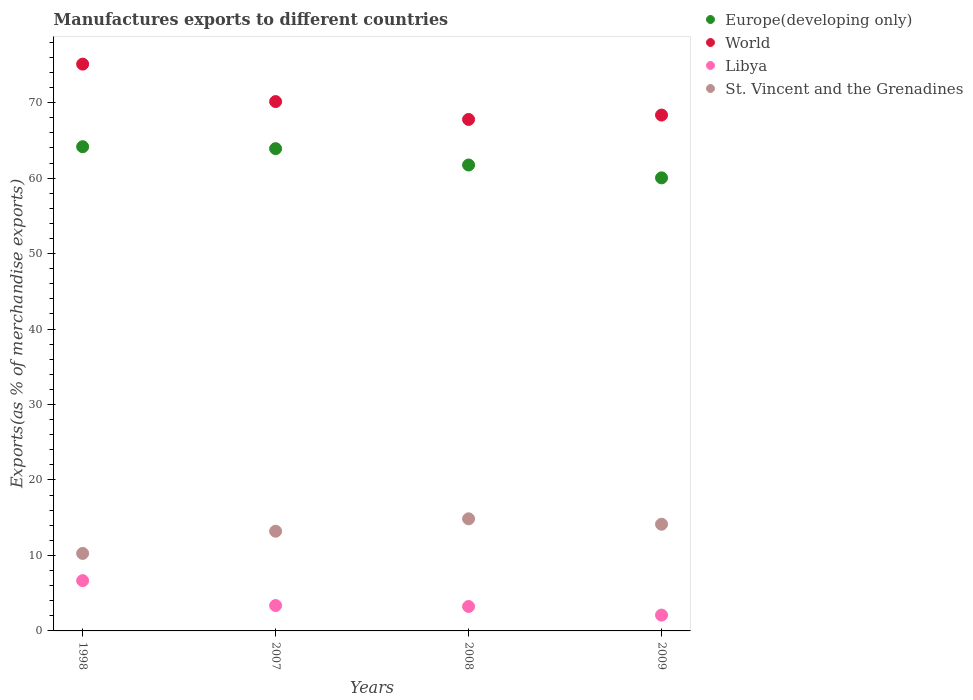Is the number of dotlines equal to the number of legend labels?
Your answer should be very brief. Yes. What is the percentage of exports to different countries in World in 1998?
Your response must be concise. 75.1. Across all years, what is the maximum percentage of exports to different countries in St. Vincent and the Grenadines?
Provide a succinct answer. 14.85. Across all years, what is the minimum percentage of exports to different countries in Libya?
Keep it short and to the point. 2.1. In which year was the percentage of exports to different countries in World maximum?
Keep it short and to the point. 1998. What is the total percentage of exports to different countries in St. Vincent and the Grenadines in the graph?
Provide a short and direct response. 52.47. What is the difference between the percentage of exports to different countries in St. Vincent and the Grenadines in 1998 and that in 2009?
Provide a succinct answer. -3.87. What is the difference between the percentage of exports to different countries in Libya in 1998 and the percentage of exports to different countries in Europe(developing only) in 2009?
Keep it short and to the point. -53.37. What is the average percentage of exports to different countries in Europe(developing only) per year?
Provide a succinct answer. 62.46. In the year 2009, what is the difference between the percentage of exports to different countries in World and percentage of exports to different countries in Europe(developing only)?
Provide a short and direct response. 8.32. In how many years, is the percentage of exports to different countries in World greater than 6 %?
Your answer should be compact. 4. What is the ratio of the percentage of exports to different countries in Europe(developing only) in 1998 to that in 2009?
Give a very brief answer. 1.07. Is the difference between the percentage of exports to different countries in World in 1998 and 2009 greater than the difference between the percentage of exports to different countries in Europe(developing only) in 1998 and 2009?
Your response must be concise. Yes. What is the difference between the highest and the second highest percentage of exports to different countries in World?
Your response must be concise. 4.96. What is the difference between the highest and the lowest percentage of exports to different countries in St. Vincent and the Grenadines?
Your answer should be very brief. 4.58. Is it the case that in every year, the sum of the percentage of exports to different countries in St. Vincent and the Grenadines and percentage of exports to different countries in Libya  is greater than the sum of percentage of exports to different countries in Europe(developing only) and percentage of exports to different countries in World?
Your answer should be very brief. No. How many dotlines are there?
Offer a terse response. 4. How many years are there in the graph?
Your answer should be very brief. 4. What is the difference between two consecutive major ticks on the Y-axis?
Provide a short and direct response. 10. Where does the legend appear in the graph?
Your answer should be compact. Top right. How many legend labels are there?
Provide a succinct answer. 4. How are the legend labels stacked?
Provide a short and direct response. Vertical. What is the title of the graph?
Provide a succinct answer. Manufactures exports to different countries. What is the label or title of the X-axis?
Provide a succinct answer. Years. What is the label or title of the Y-axis?
Your answer should be compact. Exports(as % of merchandise exports). What is the Exports(as % of merchandise exports) of Europe(developing only) in 1998?
Keep it short and to the point. 64.16. What is the Exports(as % of merchandise exports) of World in 1998?
Ensure brevity in your answer.  75.1. What is the Exports(as % of merchandise exports) of Libya in 1998?
Provide a succinct answer. 6.66. What is the Exports(as % of merchandise exports) in St. Vincent and the Grenadines in 1998?
Offer a very short reply. 10.27. What is the Exports(as % of merchandise exports) in Europe(developing only) in 2007?
Keep it short and to the point. 63.9. What is the Exports(as % of merchandise exports) of World in 2007?
Your response must be concise. 70.14. What is the Exports(as % of merchandise exports) of Libya in 2007?
Your answer should be compact. 3.36. What is the Exports(as % of merchandise exports) of St. Vincent and the Grenadines in 2007?
Provide a short and direct response. 13.21. What is the Exports(as % of merchandise exports) in Europe(developing only) in 2008?
Provide a short and direct response. 61.74. What is the Exports(as % of merchandise exports) of World in 2008?
Offer a terse response. 67.77. What is the Exports(as % of merchandise exports) of Libya in 2008?
Offer a very short reply. 3.24. What is the Exports(as % of merchandise exports) of St. Vincent and the Grenadines in 2008?
Give a very brief answer. 14.85. What is the Exports(as % of merchandise exports) of Europe(developing only) in 2009?
Your answer should be compact. 60.04. What is the Exports(as % of merchandise exports) of World in 2009?
Offer a terse response. 68.36. What is the Exports(as % of merchandise exports) in Libya in 2009?
Give a very brief answer. 2.1. What is the Exports(as % of merchandise exports) in St. Vincent and the Grenadines in 2009?
Give a very brief answer. 14.14. Across all years, what is the maximum Exports(as % of merchandise exports) in Europe(developing only)?
Provide a short and direct response. 64.16. Across all years, what is the maximum Exports(as % of merchandise exports) in World?
Your answer should be compact. 75.1. Across all years, what is the maximum Exports(as % of merchandise exports) of Libya?
Your answer should be compact. 6.66. Across all years, what is the maximum Exports(as % of merchandise exports) of St. Vincent and the Grenadines?
Keep it short and to the point. 14.85. Across all years, what is the minimum Exports(as % of merchandise exports) in Europe(developing only)?
Ensure brevity in your answer.  60.04. Across all years, what is the minimum Exports(as % of merchandise exports) in World?
Offer a terse response. 67.77. Across all years, what is the minimum Exports(as % of merchandise exports) in Libya?
Offer a very short reply. 2.1. Across all years, what is the minimum Exports(as % of merchandise exports) in St. Vincent and the Grenadines?
Offer a very short reply. 10.27. What is the total Exports(as % of merchandise exports) in Europe(developing only) in the graph?
Offer a terse response. 249.84. What is the total Exports(as % of merchandise exports) of World in the graph?
Offer a very short reply. 281.37. What is the total Exports(as % of merchandise exports) in Libya in the graph?
Provide a succinct answer. 15.36. What is the total Exports(as % of merchandise exports) of St. Vincent and the Grenadines in the graph?
Provide a short and direct response. 52.47. What is the difference between the Exports(as % of merchandise exports) in Europe(developing only) in 1998 and that in 2007?
Your answer should be very brief. 0.26. What is the difference between the Exports(as % of merchandise exports) in World in 1998 and that in 2007?
Offer a very short reply. 4.96. What is the difference between the Exports(as % of merchandise exports) in Libya in 1998 and that in 2007?
Provide a succinct answer. 3.3. What is the difference between the Exports(as % of merchandise exports) in St. Vincent and the Grenadines in 1998 and that in 2007?
Your answer should be very brief. -2.94. What is the difference between the Exports(as % of merchandise exports) of Europe(developing only) in 1998 and that in 2008?
Ensure brevity in your answer.  2.42. What is the difference between the Exports(as % of merchandise exports) in World in 1998 and that in 2008?
Keep it short and to the point. 7.33. What is the difference between the Exports(as % of merchandise exports) of Libya in 1998 and that in 2008?
Give a very brief answer. 3.42. What is the difference between the Exports(as % of merchandise exports) of St. Vincent and the Grenadines in 1998 and that in 2008?
Your answer should be compact. -4.58. What is the difference between the Exports(as % of merchandise exports) of Europe(developing only) in 1998 and that in 2009?
Keep it short and to the point. 4.13. What is the difference between the Exports(as % of merchandise exports) in World in 1998 and that in 2009?
Offer a very short reply. 6.75. What is the difference between the Exports(as % of merchandise exports) of Libya in 1998 and that in 2009?
Make the answer very short. 4.57. What is the difference between the Exports(as % of merchandise exports) of St. Vincent and the Grenadines in 1998 and that in 2009?
Provide a short and direct response. -3.87. What is the difference between the Exports(as % of merchandise exports) of Europe(developing only) in 2007 and that in 2008?
Give a very brief answer. 2.16. What is the difference between the Exports(as % of merchandise exports) of World in 2007 and that in 2008?
Your answer should be compact. 2.37. What is the difference between the Exports(as % of merchandise exports) of Libya in 2007 and that in 2008?
Provide a succinct answer. 0.13. What is the difference between the Exports(as % of merchandise exports) in St. Vincent and the Grenadines in 2007 and that in 2008?
Your answer should be very brief. -1.64. What is the difference between the Exports(as % of merchandise exports) of Europe(developing only) in 2007 and that in 2009?
Your answer should be compact. 3.87. What is the difference between the Exports(as % of merchandise exports) in World in 2007 and that in 2009?
Your answer should be very brief. 1.79. What is the difference between the Exports(as % of merchandise exports) of Libya in 2007 and that in 2009?
Your answer should be very brief. 1.27. What is the difference between the Exports(as % of merchandise exports) of St. Vincent and the Grenadines in 2007 and that in 2009?
Your answer should be very brief. -0.93. What is the difference between the Exports(as % of merchandise exports) of Europe(developing only) in 2008 and that in 2009?
Ensure brevity in your answer.  1.7. What is the difference between the Exports(as % of merchandise exports) in World in 2008 and that in 2009?
Give a very brief answer. -0.58. What is the difference between the Exports(as % of merchandise exports) in Libya in 2008 and that in 2009?
Your response must be concise. 1.14. What is the difference between the Exports(as % of merchandise exports) in St. Vincent and the Grenadines in 2008 and that in 2009?
Provide a short and direct response. 0.72. What is the difference between the Exports(as % of merchandise exports) of Europe(developing only) in 1998 and the Exports(as % of merchandise exports) of World in 2007?
Offer a terse response. -5.98. What is the difference between the Exports(as % of merchandise exports) in Europe(developing only) in 1998 and the Exports(as % of merchandise exports) in Libya in 2007?
Ensure brevity in your answer.  60.8. What is the difference between the Exports(as % of merchandise exports) of Europe(developing only) in 1998 and the Exports(as % of merchandise exports) of St. Vincent and the Grenadines in 2007?
Provide a short and direct response. 50.95. What is the difference between the Exports(as % of merchandise exports) in World in 1998 and the Exports(as % of merchandise exports) in Libya in 2007?
Keep it short and to the point. 71.74. What is the difference between the Exports(as % of merchandise exports) of World in 1998 and the Exports(as % of merchandise exports) of St. Vincent and the Grenadines in 2007?
Your answer should be very brief. 61.89. What is the difference between the Exports(as % of merchandise exports) of Libya in 1998 and the Exports(as % of merchandise exports) of St. Vincent and the Grenadines in 2007?
Offer a very short reply. -6.55. What is the difference between the Exports(as % of merchandise exports) of Europe(developing only) in 1998 and the Exports(as % of merchandise exports) of World in 2008?
Your response must be concise. -3.61. What is the difference between the Exports(as % of merchandise exports) of Europe(developing only) in 1998 and the Exports(as % of merchandise exports) of Libya in 2008?
Ensure brevity in your answer.  60.92. What is the difference between the Exports(as % of merchandise exports) in Europe(developing only) in 1998 and the Exports(as % of merchandise exports) in St. Vincent and the Grenadines in 2008?
Provide a succinct answer. 49.31. What is the difference between the Exports(as % of merchandise exports) of World in 1998 and the Exports(as % of merchandise exports) of Libya in 2008?
Make the answer very short. 71.87. What is the difference between the Exports(as % of merchandise exports) of World in 1998 and the Exports(as % of merchandise exports) of St. Vincent and the Grenadines in 2008?
Your response must be concise. 60.25. What is the difference between the Exports(as % of merchandise exports) in Libya in 1998 and the Exports(as % of merchandise exports) in St. Vincent and the Grenadines in 2008?
Give a very brief answer. -8.19. What is the difference between the Exports(as % of merchandise exports) of Europe(developing only) in 1998 and the Exports(as % of merchandise exports) of World in 2009?
Provide a succinct answer. -4.19. What is the difference between the Exports(as % of merchandise exports) of Europe(developing only) in 1998 and the Exports(as % of merchandise exports) of Libya in 2009?
Keep it short and to the point. 62.06. What is the difference between the Exports(as % of merchandise exports) of Europe(developing only) in 1998 and the Exports(as % of merchandise exports) of St. Vincent and the Grenadines in 2009?
Your answer should be compact. 50.02. What is the difference between the Exports(as % of merchandise exports) in World in 1998 and the Exports(as % of merchandise exports) in Libya in 2009?
Make the answer very short. 73.01. What is the difference between the Exports(as % of merchandise exports) in World in 1998 and the Exports(as % of merchandise exports) in St. Vincent and the Grenadines in 2009?
Provide a short and direct response. 60.97. What is the difference between the Exports(as % of merchandise exports) of Libya in 1998 and the Exports(as % of merchandise exports) of St. Vincent and the Grenadines in 2009?
Keep it short and to the point. -7.47. What is the difference between the Exports(as % of merchandise exports) in Europe(developing only) in 2007 and the Exports(as % of merchandise exports) in World in 2008?
Keep it short and to the point. -3.87. What is the difference between the Exports(as % of merchandise exports) in Europe(developing only) in 2007 and the Exports(as % of merchandise exports) in Libya in 2008?
Provide a short and direct response. 60.67. What is the difference between the Exports(as % of merchandise exports) of Europe(developing only) in 2007 and the Exports(as % of merchandise exports) of St. Vincent and the Grenadines in 2008?
Provide a succinct answer. 49.05. What is the difference between the Exports(as % of merchandise exports) of World in 2007 and the Exports(as % of merchandise exports) of Libya in 2008?
Provide a short and direct response. 66.9. What is the difference between the Exports(as % of merchandise exports) of World in 2007 and the Exports(as % of merchandise exports) of St. Vincent and the Grenadines in 2008?
Your answer should be compact. 55.29. What is the difference between the Exports(as % of merchandise exports) in Libya in 2007 and the Exports(as % of merchandise exports) in St. Vincent and the Grenadines in 2008?
Your answer should be compact. -11.49. What is the difference between the Exports(as % of merchandise exports) of Europe(developing only) in 2007 and the Exports(as % of merchandise exports) of World in 2009?
Ensure brevity in your answer.  -4.45. What is the difference between the Exports(as % of merchandise exports) in Europe(developing only) in 2007 and the Exports(as % of merchandise exports) in Libya in 2009?
Make the answer very short. 61.81. What is the difference between the Exports(as % of merchandise exports) of Europe(developing only) in 2007 and the Exports(as % of merchandise exports) of St. Vincent and the Grenadines in 2009?
Make the answer very short. 49.77. What is the difference between the Exports(as % of merchandise exports) in World in 2007 and the Exports(as % of merchandise exports) in Libya in 2009?
Keep it short and to the point. 68.04. What is the difference between the Exports(as % of merchandise exports) in World in 2007 and the Exports(as % of merchandise exports) in St. Vincent and the Grenadines in 2009?
Keep it short and to the point. 56. What is the difference between the Exports(as % of merchandise exports) in Libya in 2007 and the Exports(as % of merchandise exports) in St. Vincent and the Grenadines in 2009?
Provide a short and direct response. -10.77. What is the difference between the Exports(as % of merchandise exports) in Europe(developing only) in 2008 and the Exports(as % of merchandise exports) in World in 2009?
Make the answer very short. -6.62. What is the difference between the Exports(as % of merchandise exports) of Europe(developing only) in 2008 and the Exports(as % of merchandise exports) of Libya in 2009?
Provide a short and direct response. 59.64. What is the difference between the Exports(as % of merchandise exports) in Europe(developing only) in 2008 and the Exports(as % of merchandise exports) in St. Vincent and the Grenadines in 2009?
Offer a terse response. 47.6. What is the difference between the Exports(as % of merchandise exports) in World in 2008 and the Exports(as % of merchandise exports) in Libya in 2009?
Provide a short and direct response. 65.68. What is the difference between the Exports(as % of merchandise exports) in World in 2008 and the Exports(as % of merchandise exports) in St. Vincent and the Grenadines in 2009?
Your answer should be very brief. 53.64. What is the difference between the Exports(as % of merchandise exports) in Libya in 2008 and the Exports(as % of merchandise exports) in St. Vincent and the Grenadines in 2009?
Provide a succinct answer. -10.9. What is the average Exports(as % of merchandise exports) of Europe(developing only) per year?
Provide a succinct answer. 62.46. What is the average Exports(as % of merchandise exports) of World per year?
Ensure brevity in your answer.  70.34. What is the average Exports(as % of merchandise exports) in Libya per year?
Your answer should be very brief. 3.84. What is the average Exports(as % of merchandise exports) in St. Vincent and the Grenadines per year?
Give a very brief answer. 13.12. In the year 1998, what is the difference between the Exports(as % of merchandise exports) in Europe(developing only) and Exports(as % of merchandise exports) in World?
Provide a succinct answer. -10.94. In the year 1998, what is the difference between the Exports(as % of merchandise exports) in Europe(developing only) and Exports(as % of merchandise exports) in Libya?
Ensure brevity in your answer.  57.5. In the year 1998, what is the difference between the Exports(as % of merchandise exports) in Europe(developing only) and Exports(as % of merchandise exports) in St. Vincent and the Grenadines?
Your answer should be compact. 53.89. In the year 1998, what is the difference between the Exports(as % of merchandise exports) in World and Exports(as % of merchandise exports) in Libya?
Your answer should be very brief. 68.44. In the year 1998, what is the difference between the Exports(as % of merchandise exports) of World and Exports(as % of merchandise exports) of St. Vincent and the Grenadines?
Your response must be concise. 64.84. In the year 1998, what is the difference between the Exports(as % of merchandise exports) in Libya and Exports(as % of merchandise exports) in St. Vincent and the Grenadines?
Your answer should be compact. -3.61. In the year 2007, what is the difference between the Exports(as % of merchandise exports) of Europe(developing only) and Exports(as % of merchandise exports) of World?
Offer a very short reply. -6.24. In the year 2007, what is the difference between the Exports(as % of merchandise exports) in Europe(developing only) and Exports(as % of merchandise exports) in Libya?
Provide a short and direct response. 60.54. In the year 2007, what is the difference between the Exports(as % of merchandise exports) in Europe(developing only) and Exports(as % of merchandise exports) in St. Vincent and the Grenadines?
Your answer should be very brief. 50.69. In the year 2007, what is the difference between the Exports(as % of merchandise exports) in World and Exports(as % of merchandise exports) in Libya?
Offer a very short reply. 66.78. In the year 2007, what is the difference between the Exports(as % of merchandise exports) of World and Exports(as % of merchandise exports) of St. Vincent and the Grenadines?
Keep it short and to the point. 56.93. In the year 2007, what is the difference between the Exports(as % of merchandise exports) in Libya and Exports(as % of merchandise exports) in St. Vincent and the Grenadines?
Provide a short and direct response. -9.85. In the year 2008, what is the difference between the Exports(as % of merchandise exports) of Europe(developing only) and Exports(as % of merchandise exports) of World?
Make the answer very short. -6.03. In the year 2008, what is the difference between the Exports(as % of merchandise exports) in Europe(developing only) and Exports(as % of merchandise exports) in Libya?
Keep it short and to the point. 58.5. In the year 2008, what is the difference between the Exports(as % of merchandise exports) of Europe(developing only) and Exports(as % of merchandise exports) of St. Vincent and the Grenadines?
Give a very brief answer. 46.88. In the year 2008, what is the difference between the Exports(as % of merchandise exports) in World and Exports(as % of merchandise exports) in Libya?
Offer a terse response. 64.54. In the year 2008, what is the difference between the Exports(as % of merchandise exports) in World and Exports(as % of merchandise exports) in St. Vincent and the Grenadines?
Offer a terse response. 52.92. In the year 2008, what is the difference between the Exports(as % of merchandise exports) of Libya and Exports(as % of merchandise exports) of St. Vincent and the Grenadines?
Keep it short and to the point. -11.62. In the year 2009, what is the difference between the Exports(as % of merchandise exports) of Europe(developing only) and Exports(as % of merchandise exports) of World?
Ensure brevity in your answer.  -8.32. In the year 2009, what is the difference between the Exports(as % of merchandise exports) of Europe(developing only) and Exports(as % of merchandise exports) of Libya?
Keep it short and to the point. 57.94. In the year 2009, what is the difference between the Exports(as % of merchandise exports) in Europe(developing only) and Exports(as % of merchandise exports) in St. Vincent and the Grenadines?
Your answer should be compact. 45.9. In the year 2009, what is the difference between the Exports(as % of merchandise exports) in World and Exports(as % of merchandise exports) in Libya?
Provide a short and direct response. 66.26. In the year 2009, what is the difference between the Exports(as % of merchandise exports) of World and Exports(as % of merchandise exports) of St. Vincent and the Grenadines?
Ensure brevity in your answer.  54.22. In the year 2009, what is the difference between the Exports(as % of merchandise exports) in Libya and Exports(as % of merchandise exports) in St. Vincent and the Grenadines?
Give a very brief answer. -12.04. What is the ratio of the Exports(as % of merchandise exports) of Europe(developing only) in 1998 to that in 2007?
Offer a very short reply. 1. What is the ratio of the Exports(as % of merchandise exports) of World in 1998 to that in 2007?
Offer a terse response. 1.07. What is the ratio of the Exports(as % of merchandise exports) of Libya in 1998 to that in 2007?
Make the answer very short. 1.98. What is the ratio of the Exports(as % of merchandise exports) of St. Vincent and the Grenadines in 1998 to that in 2007?
Provide a succinct answer. 0.78. What is the ratio of the Exports(as % of merchandise exports) of Europe(developing only) in 1998 to that in 2008?
Ensure brevity in your answer.  1.04. What is the ratio of the Exports(as % of merchandise exports) in World in 1998 to that in 2008?
Provide a short and direct response. 1.11. What is the ratio of the Exports(as % of merchandise exports) of Libya in 1998 to that in 2008?
Give a very brief answer. 2.06. What is the ratio of the Exports(as % of merchandise exports) in St. Vincent and the Grenadines in 1998 to that in 2008?
Your answer should be compact. 0.69. What is the ratio of the Exports(as % of merchandise exports) of Europe(developing only) in 1998 to that in 2009?
Provide a short and direct response. 1.07. What is the ratio of the Exports(as % of merchandise exports) in World in 1998 to that in 2009?
Offer a very short reply. 1.1. What is the ratio of the Exports(as % of merchandise exports) of Libya in 1998 to that in 2009?
Provide a short and direct response. 3.18. What is the ratio of the Exports(as % of merchandise exports) of St. Vincent and the Grenadines in 1998 to that in 2009?
Offer a terse response. 0.73. What is the ratio of the Exports(as % of merchandise exports) of Europe(developing only) in 2007 to that in 2008?
Ensure brevity in your answer.  1.04. What is the ratio of the Exports(as % of merchandise exports) in World in 2007 to that in 2008?
Provide a short and direct response. 1.03. What is the ratio of the Exports(as % of merchandise exports) of Libya in 2007 to that in 2008?
Your response must be concise. 1.04. What is the ratio of the Exports(as % of merchandise exports) in St. Vincent and the Grenadines in 2007 to that in 2008?
Make the answer very short. 0.89. What is the ratio of the Exports(as % of merchandise exports) in Europe(developing only) in 2007 to that in 2009?
Give a very brief answer. 1.06. What is the ratio of the Exports(as % of merchandise exports) in World in 2007 to that in 2009?
Ensure brevity in your answer.  1.03. What is the ratio of the Exports(as % of merchandise exports) in Libya in 2007 to that in 2009?
Make the answer very short. 1.6. What is the ratio of the Exports(as % of merchandise exports) of St. Vincent and the Grenadines in 2007 to that in 2009?
Your answer should be compact. 0.93. What is the ratio of the Exports(as % of merchandise exports) in Europe(developing only) in 2008 to that in 2009?
Keep it short and to the point. 1.03. What is the ratio of the Exports(as % of merchandise exports) of World in 2008 to that in 2009?
Ensure brevity in your answer.  0.99. What is the ratio of the Exports(as % of merchandise exports) of Libya in 2008 to that in 2009?
Your response must be concise. 1.54. What is the ratio of the Exports(as % of merchandise exports) in St. Vincent and the Grenadines in 2008 to that in 2009?
Provide a succinct answer. 1.05. What is the difference between the highest and the second highest Exports(as % of merchandise exports) in Europe(developing only)?
Your answer should be compact. 0.26. What is the difference between the highest and the second highest Exports(as % of merchandise exports) in World?
Make the answer very short. 4.96. What is the difference between the highest and the second highest Exports(as % of merchandise exports) in Libya?
Your response must be concise. 3.3. What is the difference between the highest and the second highest Exports(as % of merchandise exports) of St. Vincent and the Grenadines?
Provide a succinct answer. 0.72. What is the difference between the highest and the lowest Exports(as % of merchandise exports) of Europe(developing only)?
Give a very brief answer. 4.13. What is the difference between the highest and the lowest Exports(as % of merchandise exports) of World?
Make the answer very short. 7.33. What is the difference between the highest and the lowest Exports(as % of merchandise exports) in Libya?
Give a very brief answer. 4.57. What is the difference between the highest and the lowest Exports(as % of merchandise exports) of St. Vincent and the Grenadines?
Offer a terse response. 4.58. 